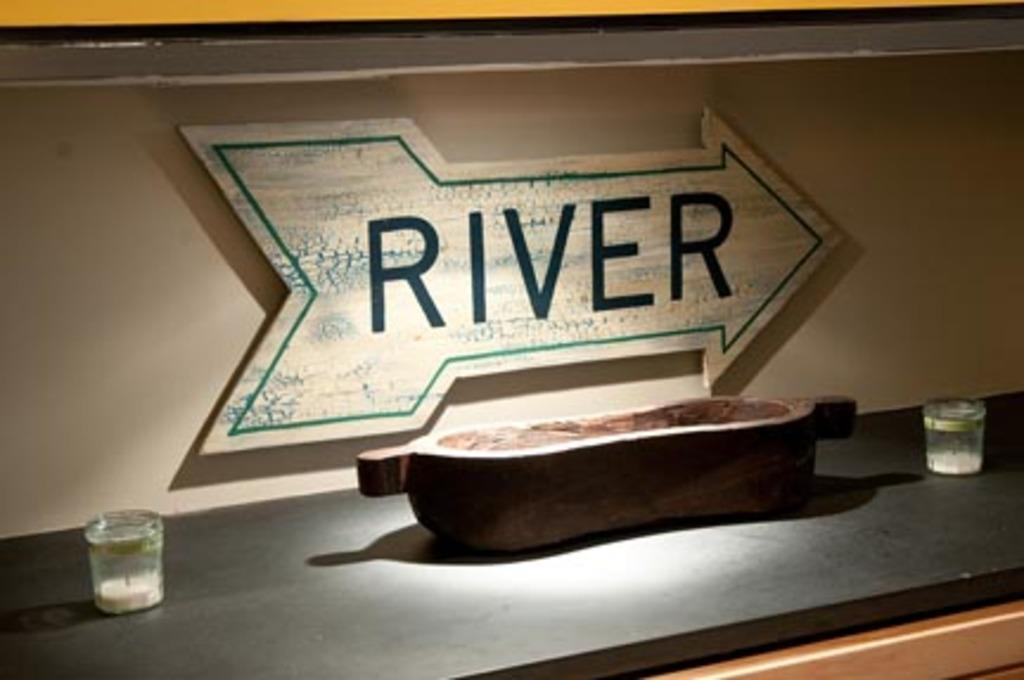<image>
Offer a succinct explanation of the picture presented. The sign tells us the River is to the right. 